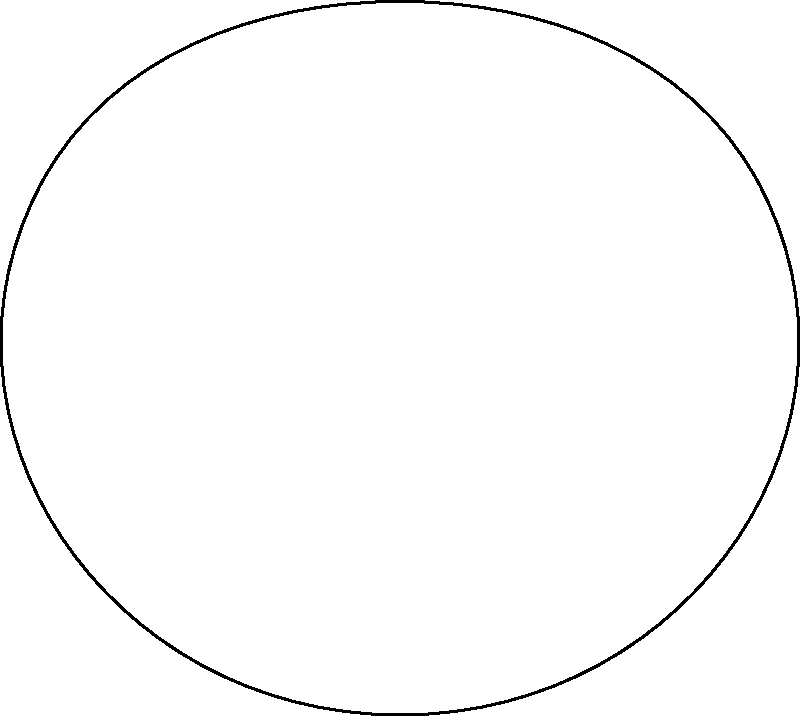Identify the primary muscle groups affected by repetitive violin playing, using the numbered anatomical illustration. Which combination of muscle groups is most likely to experience strain in aging violinists? To identify the muscle groups most affected by repetitive violin playing in aging artists, we need to consider the following steps:

1. Analyze the posture and movements involved in playing the violin:
   - Holding the violin between the shoulder and chin
   - Supporting the violin with the left arm
   - Moving the right arm to control the bow

2. Examine the muscle groups involved in these actions:
   1. Trapezius: Supports the weight of the arm and helps maintain shoulder position
   2. Deltoid: Assists in arm elevation and rotation
   3. Biceps brachii: Flexes the elbow and supinates the forearm
   4. Triceps brachii: Extends the elbow (important for bow control)
   5. Latissimus dorsi: Helps stabilize the trunk and assists in arm movements

3. Consider the impact of repetitive motions on these muscle groups:
   - The trapezius and deltoid muscles are constantly engaged to support the violin and maintain arm position
   - The biceps and triceps are repetitively used for fine motor control of the bow and fingering
   - The latissimus dorsi is involved in overall posture maintenance during playing

4. Factor in the effects of aging on muscle groups:
   - Decreased muscle mass and strength
   - Reduced flexibility and range of motion
   - Increased susceptibility to repetitive strain injuries

5. Identify the combination most likely to experience strain:
   - The trapezius and deltoid muscles bear constant load and are most prone to chronic strain
   - The biceps and triceps undergo repetitive contractions, leading to potential overuse injuries

Therefore, the combination of muscle groups most likely to experience strain in aging violinists is the trapezius, deltoid, biceps brachii, and triceps brachii.
Answer: 1, 2, 3, 4 (Trapezius, Deltoid, Biceps brachii, Triceps brachii) 